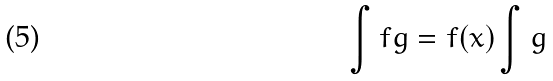Convert formula to latex. <formula><loc_0><loc_0><loc_500><loc_500>\int f g = f ( x ) \int g</formula> 